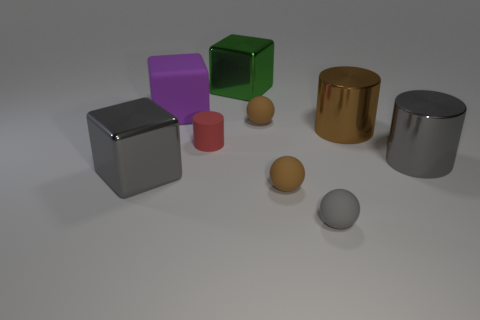Subtract all balls. How many objects are left? 6 Subtract 0 brown blocks. How many objects are left? 9 Subtract all tiny cyan balls. Subtract all red things. How many objects are left? 8 Add 1 tiny gray objects. How many tiny gray objects are left? 2 Add 8 large green cubes. How many large green cubes exist? 9 